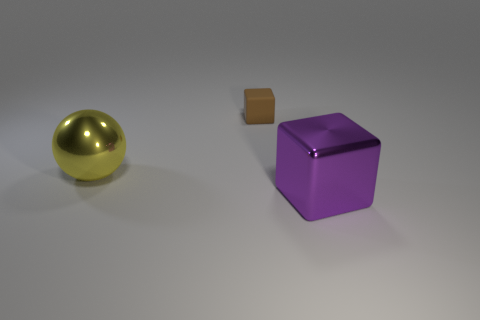Add 1 brown matte cubes. How many objects exist? 4 Subtract all purple blocks. How many blocks are left? 1 Subtract 0 cyan blocks. How many objects are left? 3 Subtract all spheres. How many objects are left? 2 Subtract 1 blocks. How many blocks are left? 1 Subtract all red balls. Subtract all green blocks. How many balls are left? 1 Subtract all brown balls. How many purple cubes are left? 1 Subtract all yellow shiny balls. Subtract all brown objects. How many objects are left? 1 Add 1 metal objects. How many metal objects are left? 3 Add 2 red matte objects. How many red matte objects exist? 2 